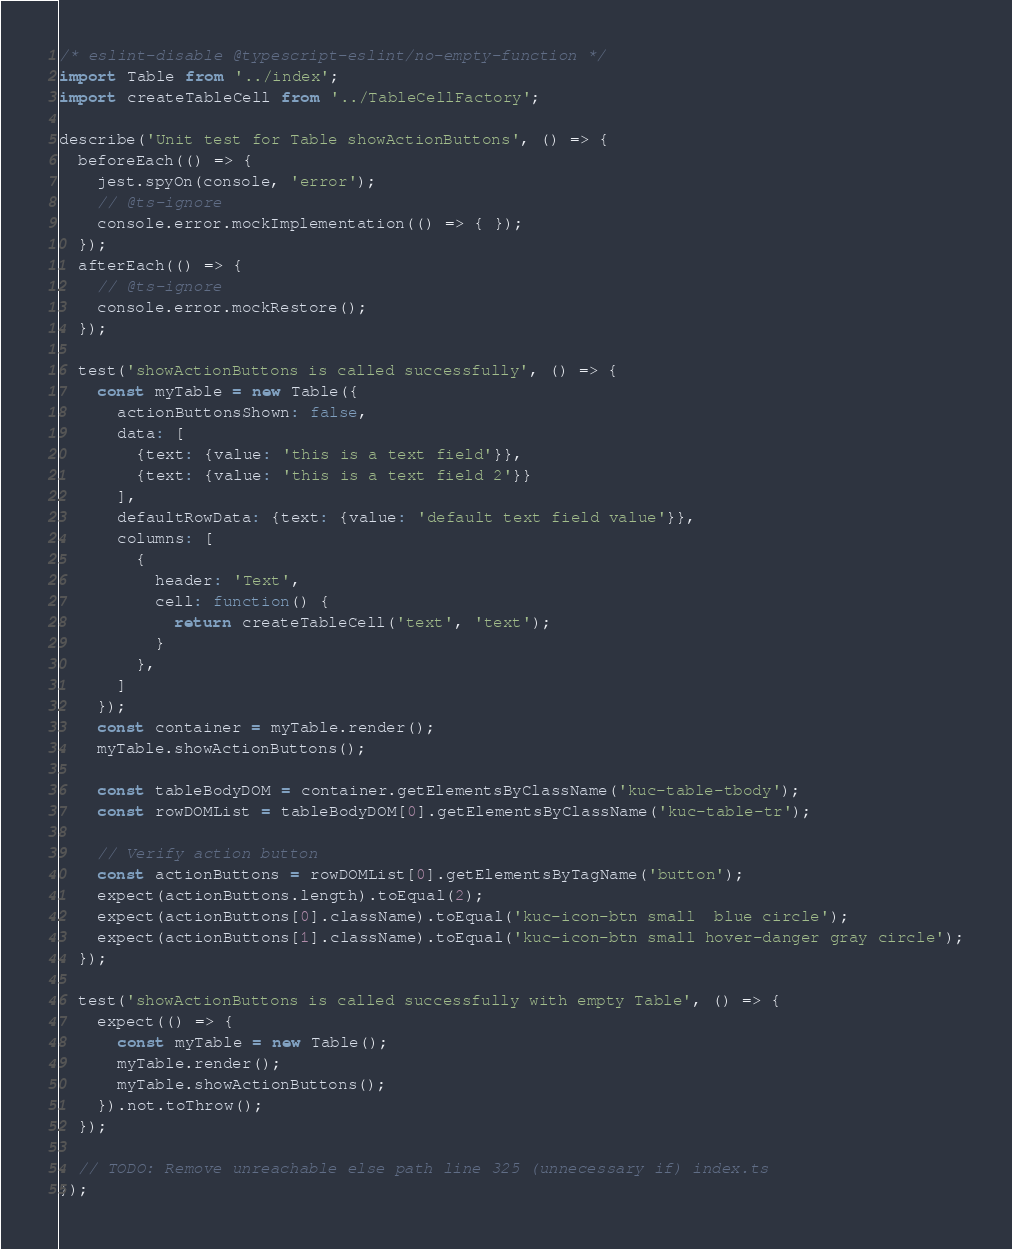<code> <loc_0><loc_0><loc_500><loc_500><_TypeScript_>/* eslint-disable @typescript-eslint/no-empty-function */
import Table from '../index';
import createTableCell from '../TableCellFactory';

describe('Unit test for Table showActionButtons', () => {
  beforeEach(() => {
    jest.spyOn(console, 'error');
    // @ts-ignore
    console.error.mockImplementation(() => { });
  });
  afterEach(() => {
    // @ts-ignore
    console.error.mockRestore();
  });

  test('showActionButtons is called successfully', () => {
    const myTable = new Table({
      actionButtonsShown: false,
      data: [
        {text: {value: 'this is a text field'}},
        {text: {value: 'this is a text field 2'}}
      ],
      defaultRowData: {text: {value: 'default text field value'}},
      columns: [
        {
          header: 'Text',
          cell: function() {
            return createTableCell('text', 'text');
          }
        },
      ]
    });
    const container = myTable.render();
    myTable.showActionButtons();

    const tableBodyDOM = container.getElementsByClassName('kuc-table-tbody');
    const rowDOMList = tableBodyDOM[0].getElementsByClassName('kuc-table-tr');

    // Verify action button
    const actionButtons = rowDOMList[0].getElementsByTagName('button');
    expect(actionButtons.length).toEqual(2);
    expect(actionButtons[0].className).toEqual('kuc-icon-btn small  blue circle');
    expect(actionButtons[1].className).toEqual('kuc-icon-btn small hover-danger gray circle');
  });

  test('showActionButtons is called successfully with empty Table', () => {
    expect(() => {
      const myTable = new Table();
      myTable.render();
      myTable.showActionButtons();
    }).not.toThrow();
  });

  // TODO: Remove unreachable else path line 325 (unnecessary if) index.ts
});</code> 